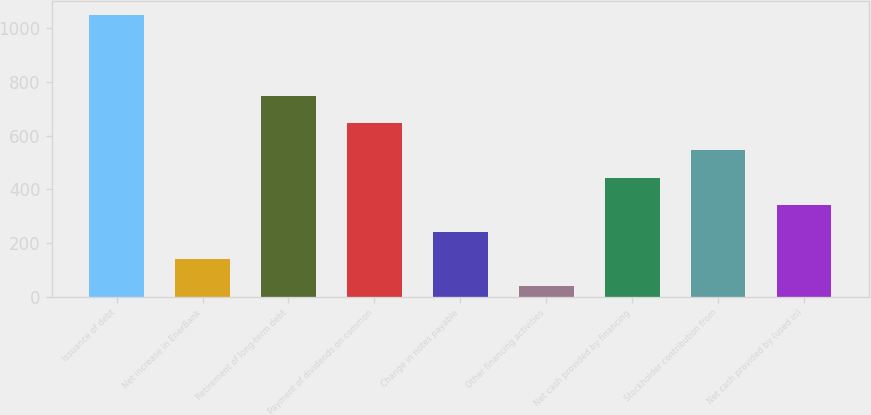Convert chart. <chart><loc_0><loc_0><loc_500><loc_500><bar_chart><fcel>Issuance of debt<fcel>Net increase in EnerBank<fcel>Retirement of long-term debt<fcel>Payment of dividends on common<fcel>Change in notes payable<fcel>Other financing activities<fcel>Net cash provided by financing<fcel>Stockholder contribution from<fcel>Net cash provided by (used in)<nl><fcel>1049<fcel>140.9<fcel>746.3<fcel>645.4<fcel>241.8<fcel>40<fcel>443.6<fcel>544.5<fcel>342.7<nl></chart> 